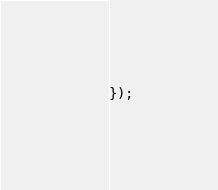<code> <loc_0><loc_0><loc_500><loc_500><_JavaScript_>});
</code> 